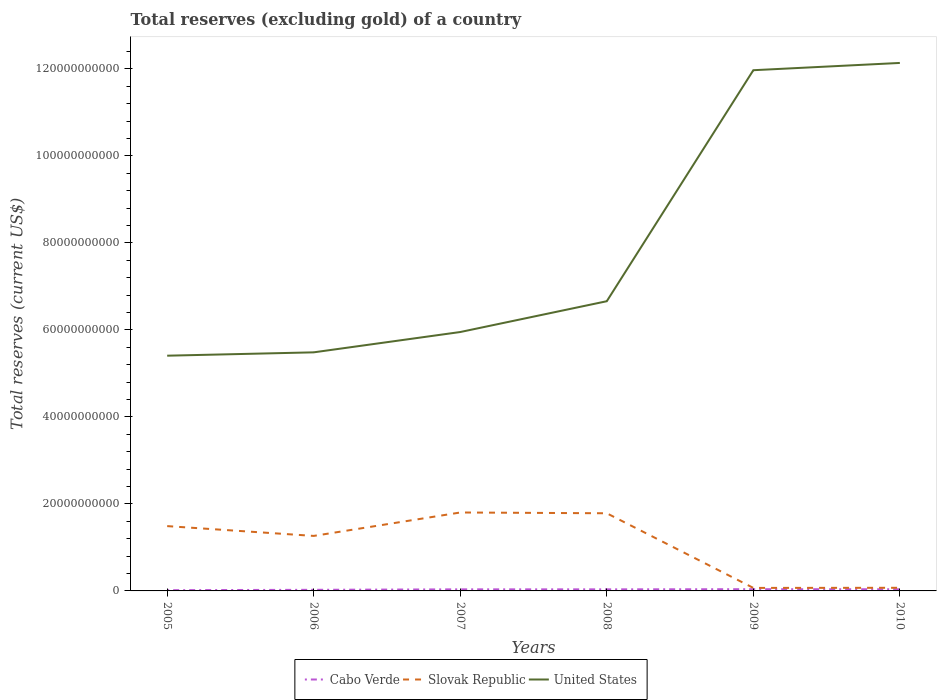How many different coloured lines are there?
Your answer should be very brief. 3. Is the number of lines equal to the number of legend labels?
Ensure brevity in your answer.  Yes. Across all years, what is the maximum total reserves (excluding gold) in Cabo Verde?
Ensure brevity in your answer.  1.74e+08. In which year was the total reserves (excluding gold) in Slovak Republic maximum?
Provide a short and direct response. 2009. What is the total total reserves (excluding gold) in United States in the graph?
Your response must be concise. -5.44e+09. What is the difference between the highest and the second highest total reserves (excluding gold) in United States?
Keep it short and to the point. 6.73e+1. What is the difference between the highest and the lowest total reserves (excluding gold) in Cabo Verde?
Offer a very short reply. 4. Is the total reserves (excluding gold) in United States strictly greater than the total reserves (excluding gold) in Slovak Republic over the years?
Ensure brevity in your answer.  No. How many years are there in the graph?
Your answer should be very brief. 6. What is the difference between two consecutive major ticks on the Y-axis?
Provide a succinct answer. 2.00e+1. Are the values on the major ticks of Y-axis written in scientific E-notation?
Your answer should be compact. No. Where does the legend appear in the graph?
Provide a succinct answer. Bottom center. How are the legend labels stacked?
Make the answer very short. Horizontal. What is the title of the graph?
Your response must be concise. Total reserves (excluding gold) of a country. What is the label or title of the Y-axis?
Your response must be concise. Total reserves (current US$). What is the Total reserves (current US$) of Cabo Verde in 2005?
Your answer should be compact. 1.74e+08. What is the Total reserves (current US$) of Slovak Republic in 2005?
Your answer should be compact. 1.49e+1. What is the Total reserves (current US$) in United States in 2005?
Your answer should be very brief. 5.41e+1. What is the Total reserves (current US$) of Cabo Verde in 2006?
Offer a terse response. 2.54e+08. What is the Total reserves (current US$) of Slovak Republic in 2006?
Keep it short and to the point. 1.26e+1. What is the Total reserves (current US$) of United States in 2006?
Ensure brevity in your answer.  5.49e+1. What is the Total reserves (current US$) in Cabo Verde in 2007?
Your answer should be very brief. 3.64e+08. What is the Total reserves (current US$) in Slovak Republic in 2007?
Offer a terse response. 1.80e+1. What is the Total reserves (current US$) in United States in 2007?
Your answer should be compact. 5.95e+1. What is the Total reserves (current US$) of Cabo Verde in 2008?
Offer a very short reply. 3.61e+08. What is the Total reserves (current US$) in Slovak Republic in 2008?
Offer a very short reply. 1.79e+1. What is the Total reserves (current US$) of United States in 2008?
Make the answer very short. 6.66e+1. What is the Total reserves (current US$) in Cabo Verde in 2009?
Offer a terse response. 3.98e+08. What is the Total reserves (current US$) of Slovak Republic in 2009?
Offer a terse response. 6.92e+08. What is the Total reserves (current US$) of United States in 2009?
Offer a terse response. 1.20e+11. What is the Total reserves (current US$) in Cabo Verde in 2010?
Offer a very short reply. 3.82e+08. What is the Total reserves (current US$) of Slovak Republic in 2010?
Provide a short and direct response. 7.19e+08. What is the Total reserves (current US$) of United States in 2010?
Your response must be concise. 1.21e+11. Across all years, what is the maximum Total reserves (current US$) in Cabo Verde?
Your response must be concise. 3.98e+08. Across all years, what is the maximum Total reserves (current US$) in Slovak Republic?
Give a very brief answer. 1.80e+1. Across all years, what is the maximum Total reserves (current US$) of United States?
Your answer should be very brief. 1.21e+11. Across all years, what is the minimum Total reserves (current US$) of Cabo Verde?
Your answer should be compact. 1.74e+08. Across all years, what is the minimum Total reserves (current US$) of Slovak Republic?
Ensure brevity in your answer.  6.92e+08. Across all years, what is the minimum Total reserves (current US$) in United States?
Make the answer very short. 5.41e+1. What is the total Total reserves (current US$) in Cabo Verde in the graph?
Ensure brevity in your answer.  1.93e+09. What is the total Total reserves (current US$) in Slovak Republic in the graph?
Make the answer very short. 6.48e+1. What is the total Total reserves (current US$) of United States in the graph?
Your answer should be compact. 4.76e+11. What is the difference between the Total reserves (current US$) in Cabo Verde in 2005 and that in 2006?
Keep it short and to the point. -8.05e+07. What is the difference between the Total reserves (current US$) in Slovak Republic in 2005 and that in 2006?
Your response must be concise. 2.25e+09. What is the difference between the Total reserves (current US$) of United States in 2005 and that in 2006?
Your answer should be compact. -7.70e+08. What is the difference between the Total reserves (current US$) in Cabo Verde in 2005 and that in 2007?
Provide a succinct answer. -1.90e+08. What is the difference between the Total reserves (current US$) of Slovak Republic in 2005 and that in 2007?
Ensure brevity in your answer.  -3.13e+09. What is the difference between the Total reserves (current US$) in United States in 2005 and that in 2007?
Your answer should be very brief. -5.44e+09. What is the difference between the Total reserves (current US$) of Cabo Verde in 2005 and that in 2008?
Your response must be concise. -1.87e+08. What is the difference between the Total reserves (current US$) of Slovak Republic in 2005 and that in 2008?
Provide a succinct answer. -2.95e+09. What is the difference between the Total reserves (current US$) in United States in 2005 and that in 2008?
Make the answer very short. -1.25e+1. What is the difference between the Total reserves (current US$) in Cabo Verde in 2005 and that in 2009?
Provide a succinct answer. -2.24e+08. What is the difference between the Total reserves (current US$) of Slovak Republic in 2005 and that in 2009?
Make the answer very short. 1.42e+1. What is the difference between the Total reserves (current US$) of United States in 2005 and that in 2009?
Make the answer very short. -6.56e+1. What is the difference between the Total reserves (current US$) of Cabo Verde in 2005 and that in 2010?
Provide a succinct answer. -2.08e+08. What is the difference between the Total reserves (current US$) in Slovak Republic in 2005 and that in 2010?
Provide a succinct answer. 1.42e+1. What is the difference between the Total reserves (current US$) in United States in 2005 and that in 2010?
Make the answer very short. -6.73e+1. What is the difference between the Total reserves (current US$) in Cabo Verde in 2006 and that in 2007?
Offer a very short reply. -1.10e+08. What is the difference between the Total reserves (current US$) in Slovak Republic in 2006 and that in 2007?
Give a very brief answer. -5.39e+09. What is the difference between the Total reserves (current US$) in United States in 2006 and that in 2007?
Keep it short and to the point. -4.67e+09. What is the difference between the Total reserves (current US$) in Cabo Verde in 2006 and that in 2008?
Provide a succinct answer. -1.07e+08. What is the difference between the Total reserves (current US$) in Slovak Republic in 2006 and that in 2008?
Provide a succinct answer. -5.21e+09. What is the difference between the Total reserves (current US$) of United States in 2006 and that in 2008?
Give a very brief answer. -1.18e+1. What is the difference between the Total reserves (current US$) in Cabo Verde in 2006 and that in 2009?
Provide a succinct answer. -1.43e+08. What is the difference between the Total reserves (current US$) of Slovak Republic in 2006 and that in 2009?
Your response must be concise. 1.20e+1. What is the difference between the Total reserves (current US$) in United States in 2006 and that in 2009?
Your response must be concise. -6.49e+1. What is the difference between the Total reserves (current US$) of Cabo Verde in 2006 and that in 2010?
Provide a succinct answer. -1.28e+08. What is the difference between the Total reserves (current US$) in Slovak Republic in 2006 and that in 2010?
Ensure brevity in your answer.  1.19e+1. What is the difference between the Total reserves (current US$) of United States in 2006 and that in 2010?
Your response must be concise. -6.65e+1. What is the difference between the Total reserves (current US$) in Cabo Verde in 2007 and that in 2008?
Ensure brevity in your answer.  3.00e+06. What is the difference between the Total reserves (current US$) of Slovak Republic in 2007 and that in 2008?
Provide a short and direct response. 1.78e+08. What is the difference between the Total reserves (current US$) of United States in 2007 and that in 2008?
Give a very brief answer. -7.08e+09. What is the difference between the Total reserves (current US$) in Cabo Verde in 2007 and that in 2009?
Provide a short and direct response. -3.34e+07. What is the difference between the Total reserves (current US$) in Slovak Republic in 2007 and that in 2009?
Make the answer very short. 1.73e+1. What is the difference between the Total reserves (current US$) of United States in 2007 and that in 2009?
Give a very brief answer. -6.02e+1. What is the difference between the Total reserves (current US$) of Cabo Verde in 2007 and that in 2010?
Offer a terse response. -1.77e+07. What is the difference between the Total reserves (current US$) of Slovak Republic in 2007 and that in 2010?
Your response must be concise. 1.73e+1. What is the difference between the Total reserves (current US$) in United States in 2007 and that in 2010?
Your answer should be very brief. -6.19e+1. What is the difference between the Total reserves (current US$) in Cabo Verde in 2008 and that in 2009?
Keep it short and to the point. -3.64e+07. What is the difference between the Total reserves (current US$) of Slovak Republic in 2008 and that in 2009?
Keep it short and to the point. 1.72e+1. What is the difference between the Total reserves (current US$) in United States in 2008 and that in 2009?
Your response must be concise. -5.31e+1. What is the difference between the Total reserves (current US$) of Cabo Verde in 2008 and that in 2010?
Keep it short and to the point. -2.07e+07. What is the difference between the Total reserves (current US$) in Slovak Republic in 2008 and that in 2010?
Make the answer very short. 1.71e+1. What is the difference between the Total reserves (current US$) of United States in 2008 and that in 2010?
Your answer should be very brief. -5.48e+1. What is the difference between the Total reserves (current US$) of Cabo Verde in 2009 and that in 2010?
Your answer should be very brief. 1.57e+07. What is the difference between the Total reserves (current US$) of Slovak Republic in 2009 and that in 2010?
Give a very brief answer. -2.71e+07. What is the difference between the Total reserves (current US$) of United States in 2009 and that in 2010?
Offer a very short reply. -1.67e+09. What is the difference between the Total reserves (current US$) of Cabo Verde in 2005 and the Total reserves (current US$) of Slovak Republic in 2006?
Provide a short and direct response. -1.25e+1. What is the difference between the Total reserves (current US$) in Cabo Verde in 2005 and the Total reserves (current US$) in United States in 2006?
Offer a terse response. -5.47e+1. What is the difference between the Total reserves (current US$) of Slovak Republic in 2005 and the Total reserves (current US$) of United States in 2006?
Your answer should be compact. -4.00e+1. What is the difference between the Total reserves (current US$) of Cabo Verde in 2005 and the Total reserves (current US$) of Slovak Republic in 2007?
Give a very brief answer. -1.79e+1. What is the difference between the Total reserves (current US$) of Cabo Verde in 2005 and the Total reserves (current US$) of United States in 2007?
Your answer should be compact. -5.94e+1. What is the difference between the Total reserves (current US$) in Slovak Republic in 2005 and the Total reserves (current US$) in United States in 2007?
Make the answer very short. -4.46e+1. What is the difference between the Total reserves (current US$) of Cabo Verde in 2005 and the Total reserves (current US$) of Slovak Republic in 2008?
Your response must be concise. -1.77e+1. What is the difference between the Total reserves (current US$) in Cabo Verde in 2005 and the Total reserves (current US$) in United States in 2008?
Your answer should be very brief. -6.64e+1. What is the difference between the Total reserves (current US$) of Slovak Republic in 2005 and the Total reserves (current US$) of United States in 2008?
Provide a short and direct response. -5.17e+1. What is the difference between the Total reserves (current US$) of Cabo Verde in 2005 and the Total reserves (current US$) of Slovak Republic in 2009?
Your answer should be compact. -5.18e+08. What is the difference between the Total reserves (current US$) of Cabo Verde in 2005 and the Total reserves (current US$) of United States in 2009?
Keep it short and to the point. -1.20e+11. What is the difference between the Total reserves (current US$) of Slovak Republic in 2005 and the Total reserves (current US$) of United States in 2009?
Provide a short and direct response. -1.05e+11. What is the difference between the Total reserves (current US$) of Cabo Verde in 2005 and the Total reserves (current US$) of Slovak Republic in 2010?
Your answer should be compact. -5.45e+08. What is the difference between the Total reserves (current US$) in Cabo Verde in 2005 and the Total reserves (current US$) in United States in 2010?
Give a very brief answer. -1.21e+11. What is the difference between the Total reserves (current US$) in Slovak Republic in 2005 and the Total reserves (current US$) in United States in 2010?
Offer a very short reply. -1.06e+11. What is the difference between the Total reserves (current US$) of Cabo Verde in 2006 and the Total reserves (current US$) of Slovak Republic in 2007?
Give a very brief answer. -1.78e+1. What is the difference between the Total reserves (current US$) in Cabo Verde in 2006 and the Total reserves (current US$) in United States in 2007?
Give a very brief answer. -5.93e+1. What is the difference between the Total reserves (current US$) in Slovak Republic in 2006 and the Total reserves (current US$) in United States in 2007?
Provide a succinct answer. -4.69e+1. What is the difference between the Total reserves (current US$) of Cabo Verde in 2006 and the Total reserves (current US$) of Slovak Republic in 2008?
Provide a short and direct response. -1.76e+1. What is the difference between the Total reserves (current US$) in Cabo Verde in 2006 and the Total reserves (current US$) in United States in 2008?
Your response must be concise. -6.64e+1. What is the difference between the Total reserves (current US$) of Slovak Republic in 2006 and the Total reserves (current US$) of United States in 2008?
Your answer should be very brief. -5.40e+1. What is the difference between the Total reserves (current US$) of Cabo Verde in 2006 and the Total reserves (current US$) of Slovak Republic in 2009?
Offer a terse response. -4.38e+08. What is the difference between the Total reserves (current US$) in Cabo Verde in 2006 and the Total reserves (current US$) in United States in 2009?
Give a very brief answer. -1.19e+11. What is the difference between the Total reserves (current US$) of Slovak Republic in 2006 and the Total reserves (current US$) of United States in 2009?
Provide a succinct answer. -1.07e+11. What is the difference between the Total reserves (current US$) in Cabo Verde in 2006 and the Total reserves (current US$) in Slovak Republic in 2010?
Keep it short and to the point. -4.65e+08. What is the difference between the Total reserves (current US$) of Cabo Verde in 2006 and the Total reserves (current US$) of United States in 2010?
Offer a terse response. -1.21e+11. What is the difference between the Total reserves (current US$) in Slovak Republic in 2006 and the Total reserves (current US$) in United States in 2010?
Ensure brevity in your answer.  -1.09e+11. What is the difference between the Total reserves (current US$) of Cabo Verde in 2007 and the Total reserves (current US$) of Slovak Republic in 2008?
Offer a terse response. -1.75e+1. What is the difference between the Total reserves (current US$) in Cabo Verde in 2007 and the Total reserves (current US$) in United States in 2008?
Provide a succinct answer. -6.62e+1. What is the difference between the Total reserves (current US$) of Slovak Republic in 2007 and the Total reserves (current US$) of United States in 2008?
Keep it short and to the point. -4.86e+1. What is the difference between the Total reserves (current US$) in Cabo Verde in 2007 and the Total reserves (current US$) in Slovak Republic in 2009?
Ensure brevity in your answer.  -3.28e+08. What is the difference between the Total reserves (current US$) of Cabo Verde in 2007 and the Total reserves (current US$) of United States in 2009?
Ensure brevity in your answer.  -1.19e+11. What is the difference between the Total reserves (current US$) in Slovak Republic in 2007 and the Total reserves (current US$) in United States in 2009?
Make the answer very short. -1.02e+11. What is the difference between the Total reserves (current US$) in Cabo Verde in 2007 and the Total reserves (current US$) in Slovak Republic in 2010?
Ensure brevity in your answer.  -3.55e+08. What is the difference between the Total reserves (current US$) of Cabo Verde in 2007 and the Total reserves (current US$) of United States in 2010?
Ensure brevity in your answer.  -1.21e+11. What is the difference between the Total reserves (current US$) in Slovak Republic in 2007 and the Total reserves (current US$) in United States in 2010?
Make the answer very short. -1.03e+11. What is the difference between the Total reserves (current US$) in Cabo Verde in 2008 and the Total reserves (current US$) in Slovak Republic in 2009?
Make the answer very short. -3.31e+08. What is the difference between the Total reserves (current US$) of Cabo Verde in 2008 and the Total reserves (current US$) of United States in 2009?
Offer a terse response. -1.19e+11. What is the difference between the Total reserves (current US$) of Slovak Republic in 2008 and the Total reserves (current US$) of United States in 2009?
Keep it short and to the point. -1.02e+11. What is the difference between the Total reserves (current US$) in Cabo Verde in 2008 and the Total reserves (current US$) in Slovak Republic in 2010?
Make the answer very short. -3.58e+08. What is the difference between the Total reserves (current US$) of Cabo Verde in 2008 and the Total reserves (current US$) of United States in 2010?
Ensure brevity in your answer.  -1.21e+11. What is the difference between the Total reserves (current US$) in Slovak Republic in 2008 and the Total reserves (current US$) in United States in 2010?
Ensure brevity in your answer.  -1.04e+11. What is the difference between the Total reserves (current US$) in Cabo Verde in 2009 and the Total reserves (current US$) in Slovak Republic in 2010?
Provide a short and direct response. -3.21e+08. What is the difference between the Total reserves (current US$) of Cabo Verde in 2009 and the Total reserves (current US$) of United States in 2010?
Make the answer very short. -1.21e+11. What is the difference between the Total reserves (current US$) of Slovak Republic in 2009 and the Total reserves (current US$) of United States in 2010?
Keep it short and to the point. -1.21e+11. What is the average Total reserves (current US$) of Cabo Verde per year?
Ensure brevity in your answer.  3.22e+08. What is the average Total reserves (current US$) of Slovak Republic per year?
Give a very brief answer. 1.08e+1. What is the average Total reserves (current US$) of United States per year?
Your answer should be very brief. 7.94e+1. In the year 2005, what is the difference between the Total reserves (current US$) of Cabo Verde and Total reserves (current US$) of Slovak Republic?
Your answer should be very brief. -1.47e+1. In the year 2005, what is the difference between the Total reserves (current US$) of Cabo Verde and Total reserves (current US$) of United States?
Your answer should be very brief. -5.39e+1. In the year 2005, what is the difference between the Total reserves (current US$) of Slovak Republic and Total reserves (current US$) of United States?
Provide a short and direct response. -3.92e+1. In the year 2006, what is the difference between the Total reserves (current US$) of Cabo Verde and Total reserves (current US$) of Slovak Republic?
Ensure brevity in your answer.  -1.24e+1. In the year 2006, what is the difference between the Total reserves (current US$) of Cabo Verde and Total reserves (current US$) of United States?
Your response must be concise. -5.46e+1. In the year 2006, what is the difference between the Total reserves (current US$) of Slovak Republic and Total reserves (current US$) of United States?
Your answer should be compact. -4.22e+1. In the year 2007, what is the difference between the Total reserves (current US$) of Cabo Verde and Total reserves (current US$) of Slovak Republic?
Your answer should be very brief. -1.77e+1. In the year 2007, what is the difference between the Total reserves (current US$) of Cabo Verde and Total reserves (current US$) of United States?
Provide a short and direct response. -5.92e+1. In the year 2007, what is the difference between the Total reserves (current US$) of Slovak Republic and Total reserves (current US$) of United States?
Your response must be concise. -4.15e+1. In the year 2008, what is the difference between the Total reserves (current US$) of Cabo Verde and Total reserves (current US$) of Slovak Republic?
Provide a short and direct response. -1.75e+1. In the year 2008, what is the difference between the Total reserves (current US$) of Cabo Verde and Total reserves (current US$) of United States?
Give a very brief answer. -6.62e+1. In the year 2008, what is the difference between the Total reserves (current US$) of Slovak Republic and Total reserves (current US$) of United States?
Make the answer very short. -4.88e+1. In the year 2009, what is the difference between the Total reserves (current US$) in Cabo Verde and Total reserves (current US$) in Slovak Republic?
Offer a very short reply. -2.94e+08. In the year 2009, what is the difference between the Total reserves (current US$) in Cabo Verde and Total reserves (current US$) in United States?
Your response must be concise. -1.19e+11. In the year 2009, what is the difference between the Total reserves (current US$) in Slovak Republic and Total reserves (current US$) in United States?
Provide a succinct answer. -1.19e+11. In the year 2010, what is the difference between the Total reserves (current US$) of Cabo Verde and Total reserves (current US$) of Slovak Republic?
Offer a terse response. -3.37e+08. In the year 2010, what is the difference between the Total reserves (current US$) in Cabo Verde and Total reserves (current US$) in United States?
Ensure brevity in your answer.  -1.21e+11. In the year 2010, what is the difference between the Total reserves (current US$) in Slovak Republic and Total reserves (current US$) in United States?
Your answer should be compact. -1.21e+11. What is the ratio of the Total reserves (current US$) in Cabo Verde in 2005 to that in 2006?
Your answer should be very brief. 0.68. What is the ratio of the Total reserves (current US$) in Slovak Republic in 2005 to that in 2006?
Offer a very short reply. 1.18. What is the ratio of the Total reserves (current US$) of Cabo Verde in 2005 to that in 2007?
Provide a succinct answer. 0.48. What is the ratio of the Total reserves (current US$) in Slovak Republic in 2005 to that in 2007?
Provide a short and direct response. 0.83. What is the ratio of the Total reserves (current US$) of United States in 2005 to that in 2007?
Keep it short and to the point. 0.91. What is the ratio of the Total reserves (current US$) in Cabo Verde in 2005 to that in 2008?
Provide a succinct answer. 0.48. What is the ratio of the Total reserves (current US$) in Slovak Republic in 2005 to that in 2008?
Your response must be concise. 0.83. What is the ratio of the Total reserves (current US$) in United States in 2005 to that in 2008?
Provide a short and direct response. 0.81. What is the ratio of the Total reserves (current US$) in Cabo Verde in 2005 to that in 2009?
Your response must be concise. 0.44. What is the ratio of the Total reserves (current US$) in Slovak Republic in 2005 to that in 2009?
Keep it short and to the point. 21.53. What is the ratio of the Total reserves (current US$) in United States in 2005 to that in 2009?
Offer a terse response. 0.45. What is the ratio of the Total reserves (current US$) in Cabo Verde in 2005 to that in 2010?
Offer a very short reply. 0.46. What is the ratio of the Total reserves (current US$) of Slovak Republic in 2005 to that in 2010?
Your answer should be compact. 20.72. What is the ratio of the Total reserves (current US$) in United States in 2005 to that in 2010?
Your answer should be compact. 0.45. What is the ratio of the Total reserves (current US$) of Cabo Verde in 2006 to that in 2007?
Keep it short and to the point. 0.7. What is the ratio of the Total reserves (current US$) of Slovak Republic in 2006 to that in 2007?
Make the answer very short. 0.7. What is the ratio of the Total reserves (current US$) in United States in 2006 to that in 2007?
Keep it short and to the point. 0.92. What is the ratio of the Total reserves (current US$) of Cabo Verde in 2006 to that in 2008?
Give a very brief answer. 0.7. What is the ratio of the Total reserves (current US$) of Slovak Republic in 2006 to that in 2008?
Your answer should be very brief. 0.71. What is the ratio of the Total reserves (current US$) in United States in 2006 to that in 2008?
Your answer should be very brief. 0.82. What is the ratio of the Total reserves (current US$) of Cabo Verde in 2006 to that in 2009?
Provide a succinct answer. 0.64. What is the ratio of the Total reserves (current US$) of Slovak Republic in 2006 to that in 2009?
Provide a succinct answer. 18.27. What is the ratio of the Total reserves (current US$) in United States in 2006 to that in 2009?
Offer a very short reply. 0.46. What is the ratio of the Total reserves (current US$) of Cabo Verde in 2006 to that in 2010?
Keep it short and to the point. 0.67. What is the ratio of the Total reserves (current US$) of Slovak Republic in 2006 to that in 2010?
Provide a succinct answer. 17.58. What is the ratio of the Total reserves (current US$) in United States in 2006 to that in 2010?
Your answer should be very brief. 0.45. What is the ratio of the Total reserves (current US$) of Cabo Verde in 2007 to that in 2008?
Offer a very short reply. 1.01. What is the ratio of the Total reserves (current US$) of United States in 2007 to that in 2008?
Provide a succinct answer. 0.89. What is the ratio of the Total reserves (current US$) of Cabo Verde in 2007 to that in 2009?
Make the answer very short. 0.92. What is the ratio of the Total reserves (current US$) in Slovak Republic in 2007 to that in 2009?
Give a very brief answer. 26.05. What is the ratio of the Total reserves (current US$) of United States in 2007 to that in 2009?
Provide a succinct answer. 0.5. What is the ratio of the Total reserves (current US$) in Cabo Verde in 2007 to that in 2010?
Keep it short and to the point. 0.95. What is the ratio of the Total reserves (current US$) in Slovak Republic in 2007 to that in 2010?
Keep it short and to the point. 25.07. What is the ratio of the Total reserves (current US$) in United States in 2007 to that in 2010?
Offer a very short reply. 0.49. What is the ratio of the Total reserves (current US$) of Cabo Verde in 2008 to that in 2009?
Offer a very short reply. 0.91. What is the ratio of the Total reserves (current US$) of Slovak Republic in 2008 to that in 2009?
Give a very brief answer. 25.79. What is the ratio of the Total reserves (current US$) of United States in 2008 to that in 2009?
Give a very brief answer. 0.56. What is the ratio of the Total reserves (current US$) of Cabo Verde in 2008 to that in 2010?
Your answer should be very brief. 0.95. What is the ratio of the Total reserves (current US$) in Slovak Republic in 2008 to that in 2010?
Offer a very short reply. 24.82. What is the ratio of the Total reserves (current US$) of United States in 2008 to that in 2010?
Your answer should be compact. 0.55. What is the ratio of the Total reserves (current US$) of Cabo Verde in 2009 to that in 2010?
Offer a very short reply. 1.04. What is the ratio of the Total reserves (current US$) in Slovak Republic in 2009 to that in 2010?
Provide a succinct answer. 0.96. What is the ratio of the Total reserves (current US$) of United States in 2009 to that in 2010?
Your answer should be compact. 0.99. What is the difference between the highest and the second highest Total reserves (current US$) in Cabo Verde?
Ensure brevity in your answer.  1.57e+07. What is the difference between the highest and the second highest Total reserves (current US$) of Slovak Republic?
Provide a short and direct response. 1.78e+08. What is the difference between the highest and the second highest Total reserves (current US$) of United States?
Your answer should be very brief. 1.67e+09. What is the difference between the highest and the lowest Total reserves (current US$) of Cabo Verde?
Offer a very short reply. 2.24e+08. What is the difference between the highest and the lowest Total reserves (current US$) of Slovak Republic?
Make the answer very short. 1.73e+1. What is the difference between the highest and the lowest Total reserves (current US$) in United States?
Keep it short and to the point. 6.73e+1. 